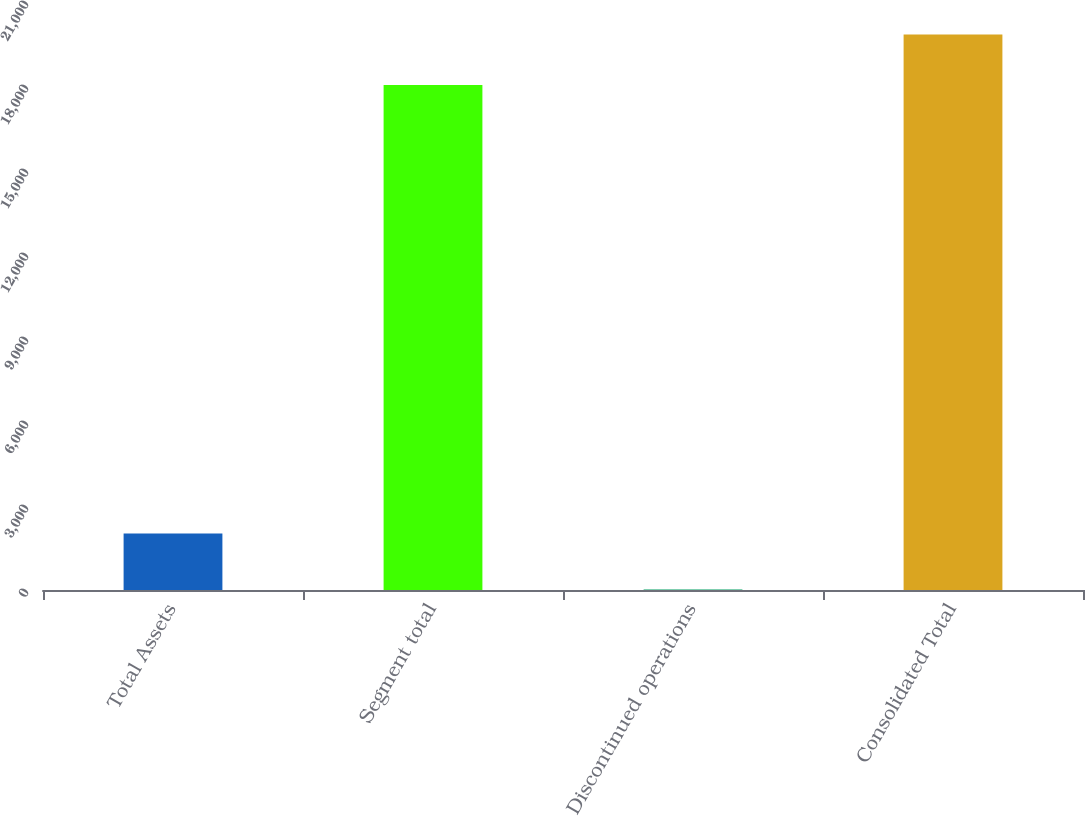Convert chart to OTSL. <chart><loc_0><loc_0><loc_500><loc_500><bar_chart><fcel>Total Assets<fcel>Segment total<fcel>Discontinued operations<fcel>Consolidated Total<nl><fcel>2016<fcel>18035.9<fcel>19.4<fcel>19839.5<nl></chart> 